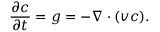Convert formula to latex. <formula><loc_0><loc_0><loc_500><loc_500>\frac { \partial c } { \partial t } = g = - \nabla \cdot ( v c ) .</formula> 